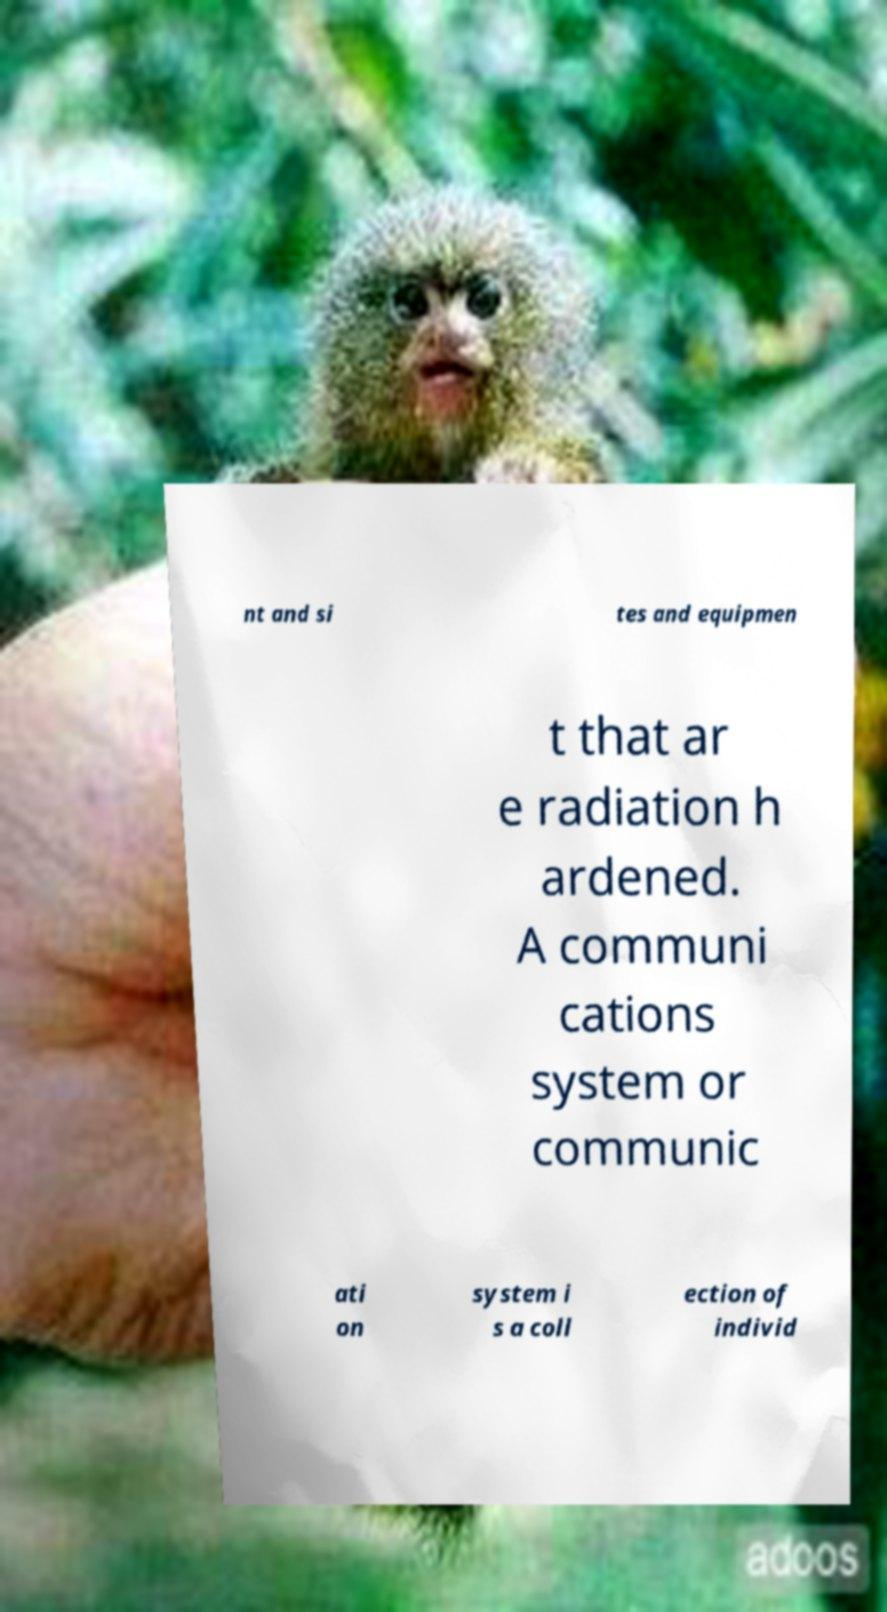What messages or text are displayed in this image? I need them in a readable, typed format. nt and si tes and equipmen t that ar e radiation h ardened. A communi cations system or communic ati on system i s a coll ection of individ 